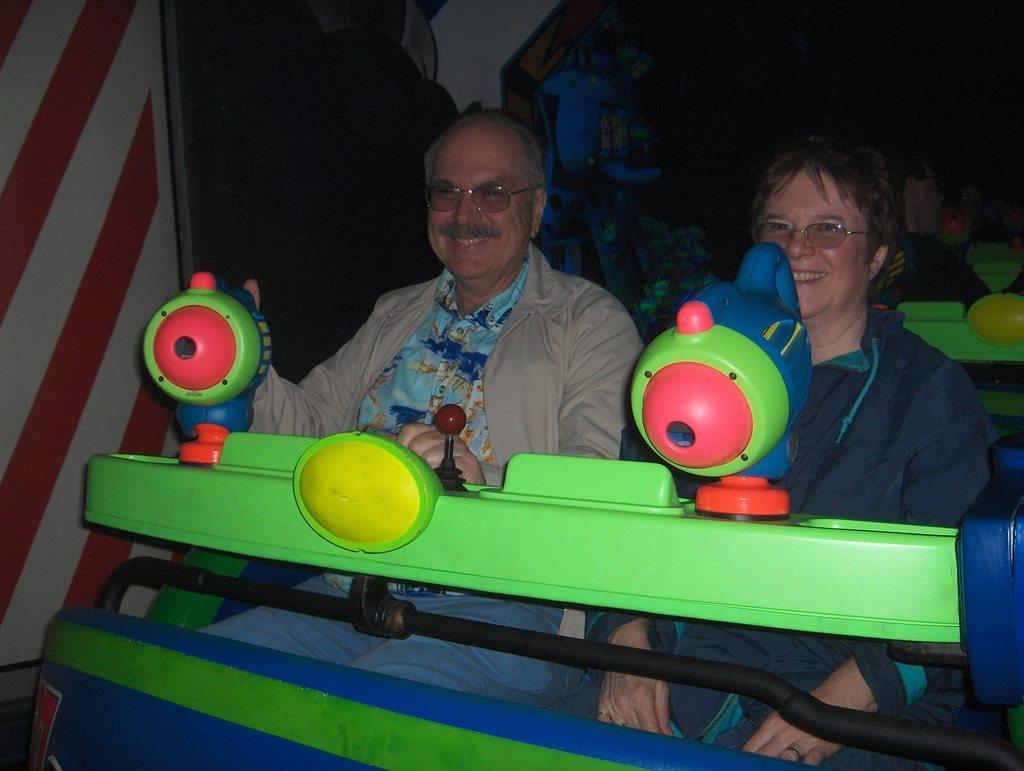Can you describe this image briefly? In this image I can see two people sitting and wearing different color dresses. I can see a multi color ride. Background is dark. 